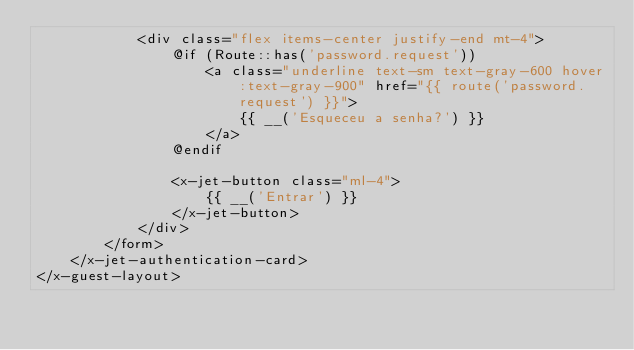Convert code to text. <code><loc_0><loc_0><loc_500><loc_500><_PHP_>            <div class="flex items-center justify-end mt-4">
                @if (Route::has('password.request'))
                    <a class="underline text-sm text-gray-600 hover:text-gray-900" href="{{ route('password.request') }}">
                        {{ __('Esqueceu a senha?') }}
                    </a>
                @endif

                <x-jet-button class="ml-4">
                    {{ __('Entrar') }}
                </x-jet-button>
            </div>
        </form>
    </x-jet-authentication-card>
</x-guest-layout>
</code> 